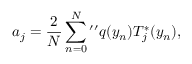<formula> <loc_0><loc_0><loc_500><loc_500>a _ { j } = \frac { 2 } { N } \sum _ { n = 0 } ^ { N ^ { \prime \prime } q ( y _ { n } ) T _ { j } ^ { * } ( y _ { n } ) ,</formula> 